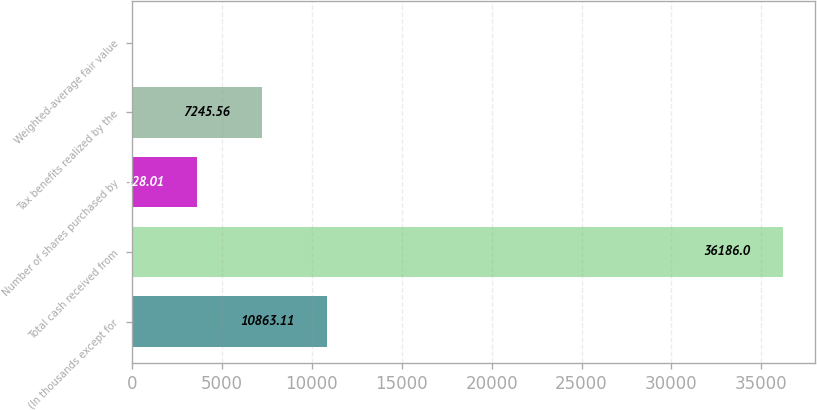Convert chart to OTSL. <chart><loc_0><loc_0><loc_500><loc_500><bar_chart><fcel>(In thousands except for<fcel>Total cash received from<fcel>Number of shares purchased by<fcel>Tax benefits realized by the<fcel>Weighted-average fair value<nl><fcel>10863.1<fcel>36186<fcel>3628.01<fcel>7245.56<fcel>10.46<nl></chart> 